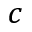Convert formula to latex. <formula><loc_0><loc_0><loc_500><loc_500>c</formula> 